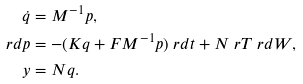Convert formula to latex. <formula><loc_0><loc_0><loc_500><loc_500>\dot { q } & = M ^ { - 1 } p , \\ \ r d p & = - ( K q + F M ^ { - 1 } p ) \ r d t + N ^ { \ } r T \ r d W , \\ y & = N q .</formula> 